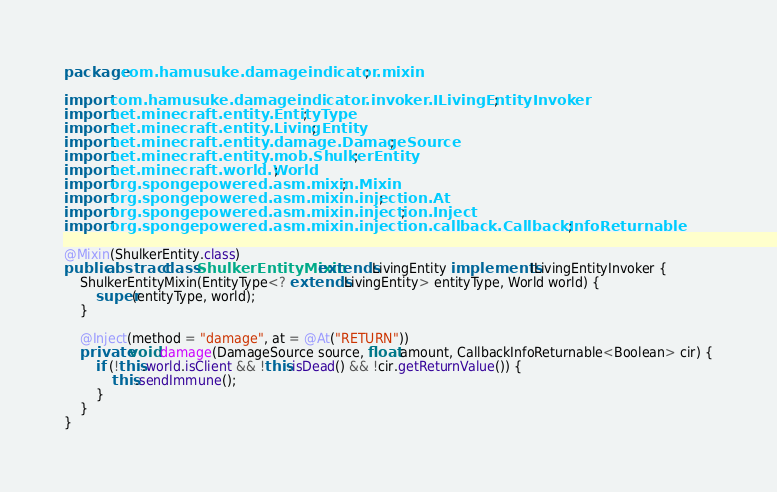<code> <loc_0><loc_0><loc_500><loc_500><_Java_>package com.hamusuke.damageindicator.mixin;

import com.hamusuke.damageindicator.invoker.ILivingEntityInvoker;
import net.minecraft.entity.EntityType;
import net.minecraft.entity.LivingEntity;
import net.minecraft.entity.damage.DamageSource;
import net.minecraft.entity.mob.ShulkerEntity;
import net.minecraft.world.World;
import org.spongepowered.asm.mixin.Mixin;
import org.spongepowered.asm.mixin.injection.At;
import org.spongepowered.asm.mixin.injection.Inject;
import org.spongepowered.asm.mixin.injection.callback.CallbackInfoReturnable;

@Mixin(ShulkerEntity.class)
public abstract class ShulkerEntityMixin extends LivingEntity implements ILivingEntityInvoker {
    ShulkerEntityMixin(EntityType<? extends LivingEntity> entityType, World world) {
        super(entityType, world);
    }

    @Inject(method = "damage", at = @At("RETURN"))
    private void damage(DamageSource source, float amount, CallbackInfoReturnable<Boolean> cir) {
        if (!this.world.isClient && !this.isDead() && !cir.getReturnValue()) {
            this.sendImmune();
        }
    }
}
</code> 